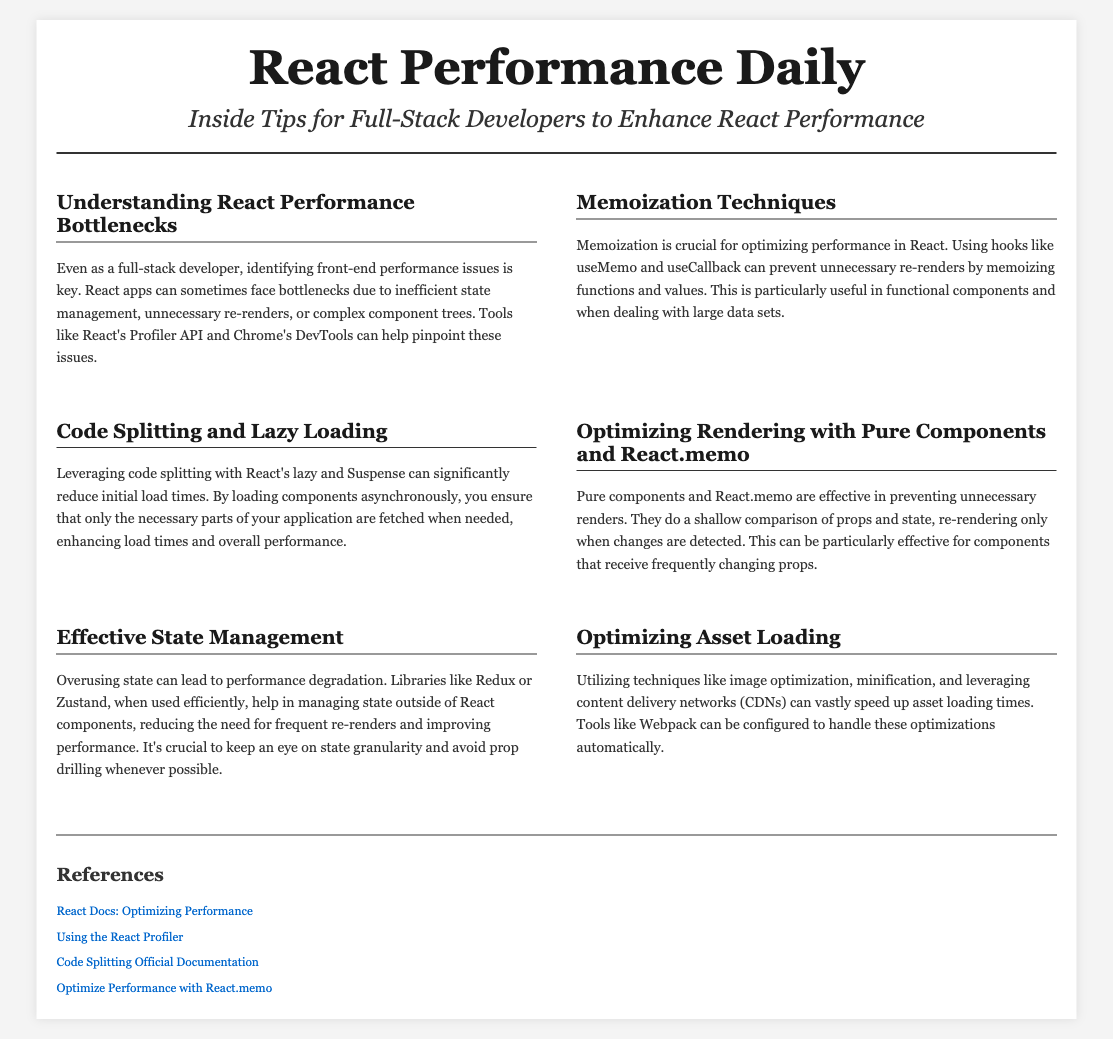What is the title of the document? The title of the document is prominently featured in the header section.
Answer: React Performance Daily What is the main theme of the document? The theme is encapsulated in the headline, indicating the focus on performance optimization.
Answer: Performance Optimization in React Which React hook is mentioned for memoization? The document mentions specific hooks that are useful for memoization in React components.
Answer: useMemo What technique is suggested for reducing initial load times? The document outlines techniques for improving performance, specifically highlighting a particular method.
Answer: Code splitting and lazy loading What is one method to optimize rendering in React? The document identifies strategies to enhance rendering efficiency, mentioning a specific technique.
Answer: Pure components and React.memo What is emphasized as crucial in managing state to avoid performance degradation? The document discusses effective approaches to state management and the importance of one specific aspect.
Answer: State granularity What does lazy loading enhance in a web application? The document explains the benefits of certain techniques for application performance, specifically addressing load times.
Answer: Load times Which content delivery optimization is mentioned? The document includes specific strategies for speeding up asset loading times, mentioning a particular resource.
Answer: CDNs What is a referenced resource for optimizing performance? The footer section lists several resources, highlighting one specific documentation link.
Answer: React Docs: Optimizing Performance 